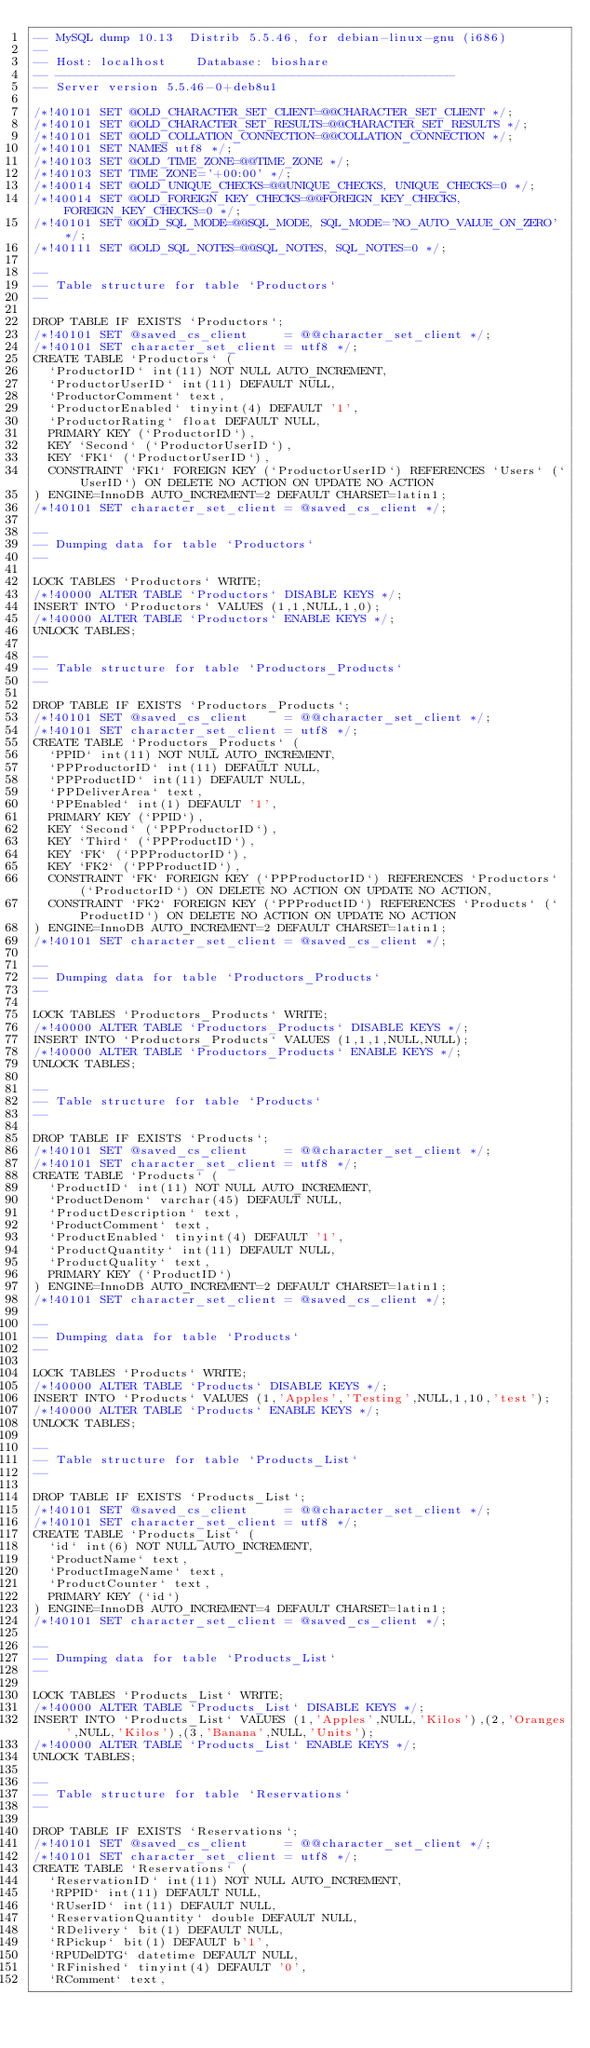Convert code to text. <code><loc_0><loc_0><loc_500><loc_500><_SQL_>-- MySQL dump 10.13  Distrib 5.5.46, for debian-linux-gnu (i686)
--
-- Host: localhost    Database: bioshare
-- ------------------------------------------------------
-- Server version	5.5.46-0+deb8u1

/*!40101 SET @OLD_CHARACTER_SET_CLIENT=@@CHARACTER_SET_CLIENT */;
/*!40101 SET @OLD_CHARACTER_SET_RESULTS=@@CHARACTER_SET_RESULTS */;
/*!40101 SET @OLD_COLLATION_CONNECTION=@@COLLATION_CONNECTION */;
/*!40101 SET NAMES utf8 */;
/*!40103 SET @OLD_TIME_ZONE=@@TIME_ZONE */;
/*!40103 SET TIME_ZONE='+00:00' */;
/*!40014 SET @OLD_UNIQUE_CHECKS=@@UNIQUE_CHECKS, UNIQUE_CHECKS=0 */;
/*!40014 SET @OLD_FOREIGN_KEY_CHECKS=@@FOREIGN_KEY_CHECKS, FOREIGN_KEY_CHECKS=0 */;
/*!40101 SET @OLD_SQL_MODE=@@SQL_MODE, SQL_MODE='NO_AUTO_VALUE_ON_ZERO' */;
/*!40111 SET @OLD_SQL_NOTES=@@SQL_NOTES, SQL_NOTES=0 */;

--
-- Table structure for table `Productors`
--

DROP TABLE IF EXISTS `Productors`;
/*!40101 SET @saved_cs_client     = @@character_set_client */;
/*!40101 SET character_set_client = utf8 */;
CREATE TABLE `Productors` (
  `ProductorID` int(11) NOT NULL AUTO_INCREMENT,
  `ProductorUserID` int(11) DEFAULT NULL,
  `ProductorComment` text,
  `ProductorEnabled` tinyint(4) DEFAULT '1',
  `ProductorRating` float DEFAULT NULL,
  PRIMARY KEY (`ProductorID`),
  KEY `Second` (`ProductorUserID`),
  KEY `FK1` (`ProductorUserID`),
  CONSTRAINT `FK1` FOREIGN KEY (`ProductorUserID`) REFERENCES `Users` (`UserID`) ON DELETE NO ACTION ON UPDATE NO ACTION
) ENGINE=InnoDB AUTO_INCREMENT=2 DEFAULT CHARSET=latin1;
/*!40101 SET character_set_client = @saved_cs_client */;

--
-- Dumping data for table `Productors`
--

LOCK TABLES `Productors` WRITE;
/*!40000 ALTER TABLE `Productors` DISABLE KEYS */;
INSERT INTO `Productors` VALUES (1,1,NULL,1,0);
/*!40000 ALTER TABLE `Productors` ENABLE KEYS */;
UNLOCK TABLES;

--
-- Table structure for table `Productors_Products`
--

DROP TABLE IF EXISTS `Productors_Products`;
/*!40101 SET @saved_cs_client     = @@character_set_client */;
/*!40101 SET character_set_client = utf8 */;
CREATE TABLE `Productors_Products` (
  `PPID` int(11) NOT NULL AUTO_INCREMENT,
  `PPProductorID` int(11) DEFAULT NULL,
  `PPProductID` int(11) DEFAULT NULL,
  `PPDeliverArea` text,
  `PPEnabled` int(1) DEFAULT '1',
  PRIMARY KEY (`PPID`),
  KEY `Second` (`PPProductorID`),
  KEY `Third` (`PPProductID`),
  KEY `FK` (`PPProductorID`),
  KEY `FK2` (`PPProductID`),
  CONSTRAINT `FK` FOREIGN KEY (`PPProductorID`) REFERENCES `Productors` (`ProductorID`) ON DELETE NO ACTION ON UPDATE NO ACTION,
  CONSTRAINT `FK2` FOREIGN KEY (`PPProductID`) REFERENCES `Products` (`ProductID`) ON DELETE NO ACTION ON UPDATE NO ACTION
) ENGINE=InnoDB AUTO_INCREMENT=2 DEFAULT CHARSET=latin1;
/*!40101 SET character_set_client = @saved_cs_client */;

--
-- Dumping data for table `Productors_Products`
--

LOCK TABLES `Productors_Products` WRITE;
/*!40000 ALTER TABLE `Productors_Products` DISABLE KEYS */;
INSERT INTO `Productors_Products` VALUES (1,1,1,NULL,NULL);
/*!40000 ALTER TABLE `Productors_Products` ENABLE KEYS */;
UNLOCK TABLES;

--
-- Table structure for table `Products`
--

DROP TABLE IF EXISTS `Products`;
/*!40101 SET @saved_cs_client     = @@character_set_client */;
/*!40101 SET character_set_client = utf8 */;
CREATE TABLE `Products` (
  `ProductID` int(11) NOT NULL AUTO_INCREMENT,
  `ProductDenom` varchar(45) DEFAULT NULL,
  `ProductDescription` text,
  `ProductComment` text,
  `ProductEnabled` tinyint(4) DEFAULT '1',
  `ProductQuantity` int(11) DEFAULT NULL,
  `ProductQuality` text,
  PRIMARY KEY (`ProductID`)
) ENGINE=InnoDB AUTO_INCREMENT=2 DEFAULT CHARSET=latin1;
/*!40101 SET character_set_client = @saved_cs_client */;

--
-- Dumping data for table `Products`
--

LOCK TABLES `Products` WRITE;
/*!40000 ALTER TABLE `Products` DISABLE KEYS */;
INSERT INTO `Products` VALUES (1,'Apples','Testing',NULL,1,10,'test');
/*!40000 ALTER TABLE `Products` ENABLE KEYS */;
UNLOCK TABLES;

--
-- Table structure for table `Products_List`
--

DROP TABLE IF EXISTS `Products_List`;
/*!40101 SET @saved_cs_client     = @@character_set_client */;
/*!40101 SET character_set_client = utf8 */;
CREATE TABLE `Products_List` (
  `id` int(6) NOT NULL AUTO_INCREMENT,
  `ProductName` text,
  `ProductImageName` text,
  `ProductCounter` text,
  PRIMARY KEY (`id`)
) ENGINE=InnoDB AUTO_INCREMENT=4 DEFAULT CHARSET=latin1;
/*!40101 SET character_set_client = @saved_cs_client */;

--
-- Dumping data for table `Products_List`
--

LOCK TABLES `Products_List` WRITE;
/*!40000 ALTER TABLE `Products_List` DISABLE KEYS */;
INSERT INTO `Products_List` VALUES (1,'Apples',NULL,'Kilos'),(2,'Oranges',NULL,'Kilos'),(3,'Banana',NULL,'Units');
/*!40000 ALTER TABLE `Products_List` ENABLE KEYS */;
UNLOCK TABLES;

--
-- Table structure for table `Reservations`
--

DROP TABLE IF EXISTS `Reservations`;
/*!40101 SET @saved_cs_client     = @@character_set_client */;
/*!40101 SET character_set_client = utf8 */;
CREATE TABLE `Reservations` (
  `ReservationID` int(11) NOT NULL AUTO_INCREMENT,
  `RPPID` int(11) DEFAULT NULL,
  `RUserID` int(11) DEFAULT NULL,
  `ReservationQuantity` double DEFAULT NULL,
  `RDelivery` bit(1) DEFAULT NULL,
  `RPickup` bit(1) DEFAULT b'1',
  `RPUDelDTG` datetime DEFAULT NULL,
  `RFinished` tinyint(4) DEFAULT '0',
  `RComment` text,</code> 